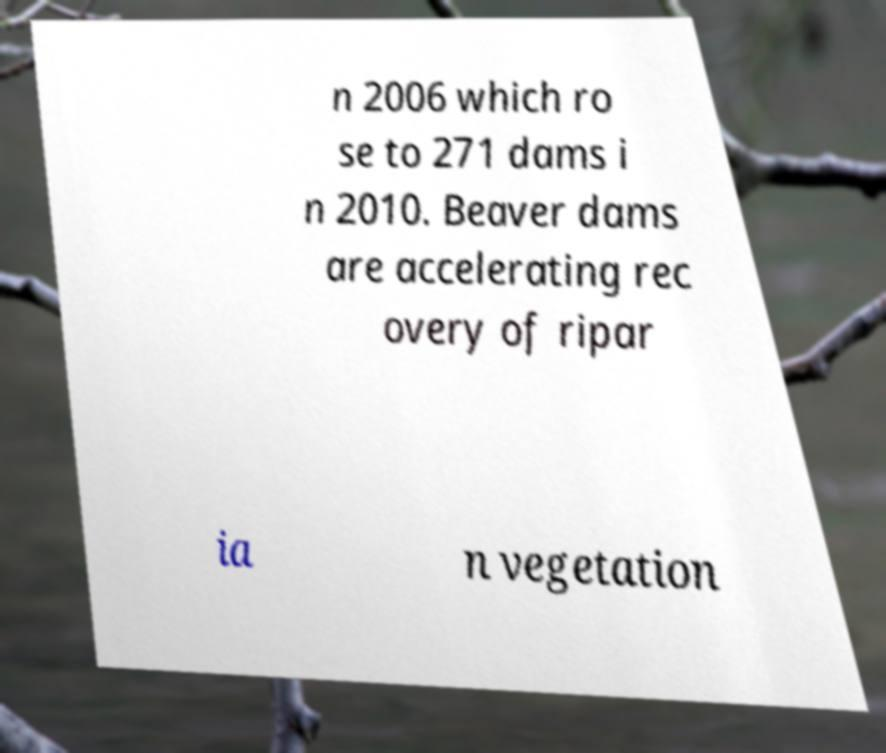Could you extract and type out the text from this image? n 2006 which ro se to 271 dams i n 2010. Beaver dams are accelerating rec overy of ripar ia n vegetation 